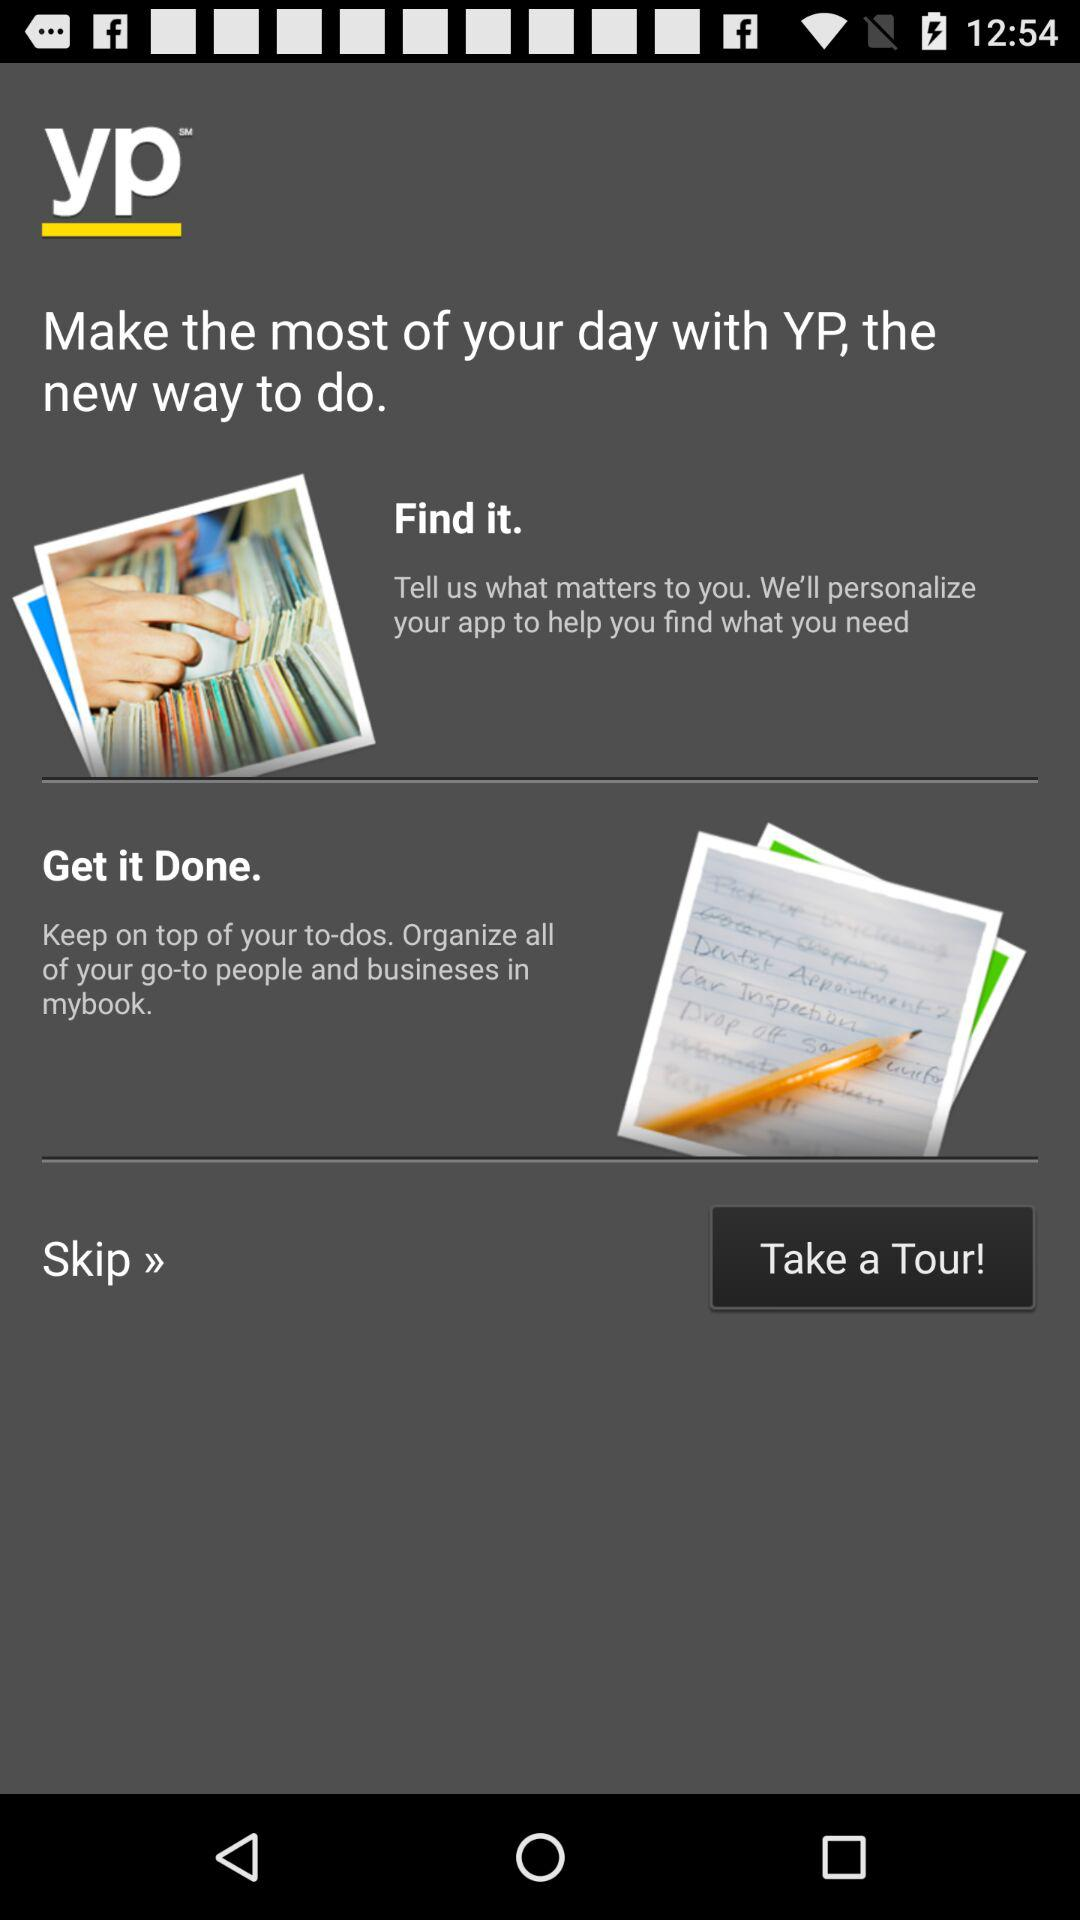What is the name of the application? The name of the application is "YP". 